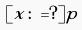Convert formula to latex. <formula><loc_0><loc_0><loc_500><loc_500>[ x \colon = ? ] p</formula> 